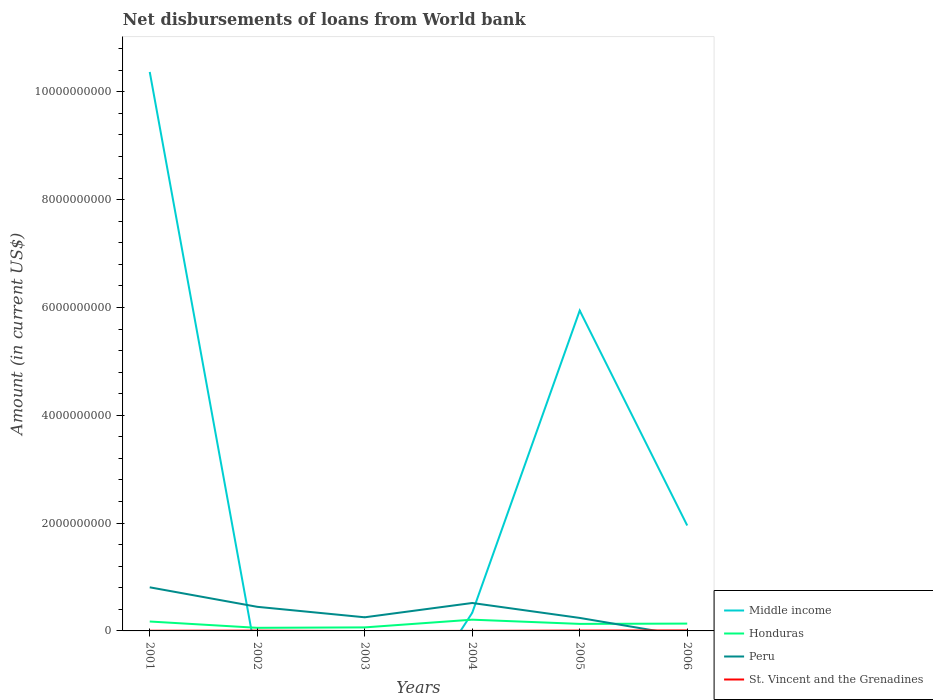Does the line corresponding to Peru intersect with the line corresponding to Honduras?
Give a very brief answer. Yes. Is the number of lines equal to the number of legend labels?
Make the answer very short. No. What is the total amount of loan disbursed from World Bank in St. Vincent and the Grenadines in the graph?
Offer a terse response. -5.86e+06. What is the difference between the highest and the second highest amount of loan disbursed from World Bank in St. Vincent and the Grenadines?
Your answer should be compact. 8.95e+06. How many lines are there?
Ensure brevity in your answer.  4. Where does the legend appear in the graph?
Make the answer very short. Bottom right. How many legend labels are there?
Offer a terse response. 4. How are the legend labels stacked?
Keep it short and to the point. Vertical. What is the title of the graph?
Provide a succinct answer. Net disbursements of loans from World bank. Does "Cayman Islands" appear as one of the legend labels in the graph?
Your response must be concise. No. What is the label or title of the X-axis?
Make the answer very short. Years. What is the Amount (in current US$) of Middle income in 2001?
Provide a short and direct response. 1.04e+1. What is the Amount (in current US$) in Honduras in 2001?
Make the answer very short. 1.75e+08. What is the Amount (in current US$) in Peru in 2001?
Offer a very short reply. 8.09e+08. What is the Amount (in current US$) in St. Vincent and the Grenadines in 2001?
Provide a succinct answer. 3.09e+06. What is the Amount (in current US$) in Middle income in 2002?
Provide a succinct answer. 0. What is the Amount (in current US$) in Honduras in 2002?
Keep it short and to the point. 5.75e+07. What is the Amount (in current US$) in Peru in 2002?
Provide a succinct answer. 4.47e+08. What is the Amount (in current US$) in St. Vincent and the Grenadines in 2002?
Your answer should be very brief. 5.45e+06. What is the Amount (in current US$) in Middle income in 2003?
Your answer should be very brief. 0. What is the Amount (in current US$) in Honduras in 2003?
Offer a very short reply. 6.55e+07. What is the Amount (in current US$) of Peru in 2003?
Give a very brief answer. 2.53e+08. What is the Amount (in current US$) of St. Vincent and the Grenadines in 2003?
Offer a terse response. 0. What is the Amount (in current US$) in Middle income in 2004?
Provide a short and direct response. 3.36e+08. What is the Amount (in current US$) in Honduras in 2004?
Your answer should be compact. 2.09e+08. What is the Amount (in current US$) of Peru in 2004?
Your answer should be compact. 5.18e+08. What is the Amount (in current US$) of St. Vincent and the Grenadines in 2004?
Offer a terse response. 4.46e+05. What is the Amount (in current US$) in Middle income in 2005?
Keep it short and to the point. 5.94e+09. What is the Amount (in current US$) of Honduras in 2005?
Your response must be concise. 1.31e+08. What is the Amount (in current US$) of Peru in 2005?
Your answer should be very brief. 2.41e+08. What is the Amount (in current US$) in St. Vincent and the Grenadines in 2005?
Your answer should be compact. 6.60e+06. What is the Amount (in current US$) of Middle income in 2006?
Ensure brevity in your answer.  1.96e+09. What is the Amount (in current US$) in Honduras in 2006?
Provide a succinct answer. 1.36e+08. What is the Amount (in current US$) of Peru in 2006?
Provide a short and direct response. 0. What is the Amount (in current US$) of St. Vincent and the Grenadines in 2006?
Ensure brevity in your answer.  8.95e+06. Across all years, what is the maximum Amount (in current US$) in Middle income?
Your response must be concise. 1.04e+1. Across all years, what is the maximum Amount (in current US$) in Honduras?
Offer a terse response. 2.09e+08. Across all years, what is the maximum Amount (in current US$) of Peru?
Your answer should be very brief. 8.09e+08. Across all years, what is the maximum Amount (in current US$) of St. Vincent and the Grenadines?
Keep it short and to the point. 8.95e+06. Across all years, what is the minimum Amount (in current US$) in Middle income?
Offer a terse response. 0. Across all years, what is the minimum Amount (in current US$) in Honduras?
Make the answer very short. 5.75e+07. Across all years, what is the minimum Amount (in current US$) of Peru?
Make the answer very short. 0. Across all years, what is the minimum Amount (in current US$) of St. Vincent and the Grenadines?
Ensure brevity in your answer.  0. What is the total Amount (in current US$) of Middle income in the graph?
Make the answer very short. 1.86e+1. What is the total Amount (in current US$) in Honduras in the graph?
Offer a terse response. 7.73e+08. What is the total Amount (in current US$) of Peru in the graph?
Your answer should be compact. 2.27e+09. What is the total Amount (in current US$) of St. Vincent and the Grenadines in the graph?
Ensure brevity in your answer.  2.45e+07. What is the difference between the Amount (in current US$) in Honduras in 2001 and that in 2002?
Make the answer very short. 1.17e+08. What is the difference between the Amount (in current US$) of Peru in 2001 and that in 2002?
Make the answer very short. 3.62e+08. What is the difference between the Amount (in current US$) of St. Vincent and the Grenadines in 2001 and that in 2002?
Make the answer very short. -2.36e+06. What is the difference between the Amount (in current US$) in Honduras in 2001 and that in 2003?
Your response must be concise. 1.09e+08. What is the difference between the Amount (in current US$) of Peru in 2001 and that in 2003?
Ensure brevity in your answer.  5.56e+08. What is the difference between the Amount (in current US$) of Middle income in 2001 and that in 2004?
Offer a very short reply. 1.00e+1. What is the difference between the Amount (in current US$) of Honduras in 2001 and that in 2004?
Your response must be concise. -3.41e+07. What is the difference between the Amount (in current US$) in Peru in 2001 and that in 2004?
Your answer should be very brief. 2.91e+08. What is the difference between the Amount (in current US$) in St. Vincent and the Grenadines in 2001 and that in 2004?
Keep it short and to the point. 2.64e+06. What is the difference between the Amount (in current US$) in Middle income in 2001 and that in 2005?
Provide a short and direct response. 4.43e+09. What is the difference between the Amount (in current US$) in Honduras in 2001 and that in 2005?
Provide a short and direct response. 4.41e+07. What is the difference between the Amount (in current US$) of Peru in 2001 and that in 2005?
Offer a terse response. 5.68e+08. What is the difference between the Amount (in current US$) of St. Vincent and the Grenadines in 2001 and that in 2005?
Ensure brevity in your answer.  -3.51e+06. What is the difference between the Amount (in current US$) of Middle income in 2001 and that in 2006?
Make the answer very short. 8.41e+09. What is the difference between the Amount (in current US$) of Honduras in 2001 and that in 2006?
Provide a short and direct response. 3.87e+07. What is the difference between the Amount (in current US$) of St. Vincent and the Grenadines in 2001 and that in 2006?
Your answer should be very brief. -5.86e+06. What is the difference between the Amount (in current US$) of Honduras in 2002 and that in 2003?
Offer a very short reply. -8.01e+06. What is the difference between the Amount (in current US$) in Peru in 2002 and that in 2003?
Offer a very short reply. 1.94e+08. What is the difference between the Amount (in current US$) in Honduras in 2002 and that in 2004?
Your response must be concise. -1.51e+08. What is the difference between the Amount (in current US$) of Peru in 2002 and that in 2004?
Offer a terse response. -7.11e+07. What is the difference between the Amount (in current US$) of St. Vincent and the Grenadines in 2002 and that in 2004?
Your answer should be compact. 5.00e+06. What is the difference between the Amount (in current US$) in Honduras in 2002 and that in 2005?
Offer a very short reply. -7.30e+07. What is the difference between the Amount (in current US$) of Peru in 2002 and that in 2005?
Provide a short and direct response. 2.06e+08. What is the difference between the Amount (in current US$) in St. Vincent and the Grenadines in 2002 and that in 2005?
Your answer should be compact. -1.15e+06. What is the difference between the Amount (in current US$) in Honduras in 2002 and that in 2006?
Provide a succinct answer. -7.85e+07. What is the difference between the Amount (in current US$) of St. Vincent and the Grenadines in 2002 and that in 2006?
Offer a very short reply. -3.50e+06. What is the difference between the Amount (in current US$) of Honduras in 2003 and that in 2004?
Offer a terse response. -1.43e+08. What is the difference between the Amount (in current US$) of Peru in 2003 and that in 2004?
Your answer should be compact. -2.65e+08. What is the difference between the Amount (in current US$) in Honduras in 2003 and that in 2005?
Ensure brevity in your answer.  -6.50e+07. What is the difference between the Amount (in current US$) of Peru in 2003 and that in 2005?
Make the answer very short. 1.18e+07. What is the difference between the Amount (in current US$) of Honduras in 2003 and that in 2006?
Your answer should be compact. -7.04e+07. What is the difference between the Amount (in current US$) of Middle income in 2004 and that in 2005?
Provide a succinct answer. -5.61e+09. What is the difference between the Amount (in current US$) in Honduras in 2004 and that in 2005?
Your response must be concise. 7.82e+07. What is the difference between the Amount (in current US$) in Peru in 2004 and that in 2005?
Your answer should be compact. 2.77e+08. What is the difference between the Amount (in current US$) of St. Vincent and the Grenadines in 2004 and that in 2005?
Your answer should be very brief. -6.16e+06. What is the difference between the Amount (in current US$) in Middle income in 2004 and that in 2006?
Provide a succinct answer. -1.62e+09. What is the difference between the Amount (in current US$) of Honduras in 2004 and that in 2006?
Give a very brief answer. 7.27e+07. What is the difference between the Amount (in current US$) of St. Vincent and the Grenadines in 2004 and that in 2006?
Offer a very short reply. -8.50e+06. What is the difference between the Amount (in current US$) in Middle income in 2005 and that in 2006?
Your answer should be very brief. 3.99e+09. What is the difference between the Amount (in current US$) of Honduras in 2005 and that in 2006?
Make the answer very short. -5.49e+06. What is the difference between the Amount (in current US$) of St. Vincent and the Grenadines in 2005 and that in 2006?
Ensure brevity in your answer.  -2.34e+06. What is the difference between the Amount (in current US$) in Middle income in 2001 and the Amount (in current US$) in Honduras in 2002?
Your response must be concise. 1.03e+1. What is the difference between the Amount (in current US$) of Middle income in 2001 and the Amount (in current US$) of Peru in 2002?
Provide a short and direct response. 9.92e+09. What is the difference between the Amount (in current US$) in Middle income in 2001 and the Amount (in current US$) in St. Vincent and the Grenadines in 2002?
Your answer should be compact. 1.04e+1. What is the difference between the Amount (in current US$) of Honduras in 2001 and the Amount (in current US$) of Peru in 2002?
Make the answer very short. -2.72e+08. What is the difference between the Amount (in current US$) of Honduras in 2001 and the Amount (in current US$) of St. Vincent and the Grenadines in 2002?
Ensure brevity in your answer.  1.69e+08. What is the difference between the Amount (in current US$) of Peru in 2001 and the Amount (in current US$) of St. Vincent and the Grenadines in 2002?
Ensure brevity in your answer.  8.03e+08. What is the difference between the Amount (in current US$) of Middle income in 2001 and the Amount (in current US$) of Honduras in 2003?
Make the answer very short. 1.03e+1. What is the difference between the Amount (in current US$) in Middle income in 2001 and the Amount (in current US$) in Peru in 2003?
Offer a terse response. 1.01e+1. What is the difference between the Amount (in current US$) in Honduras in 2001 and the Amount (in current US$) in Peru in 2003?
Give a very brief answer. -7.83e+07. What is the difference between the Amount (in current US$) in Middle income in 2001 and the Amount (in current US$) in Honduras in 2004?
Your response must be concise. 1.02e+1. What is the difference between the Amount (in current US$) of Middle income in 2001 and the Amount (in current US$) of Peru in 2004?
Keep it short and to the point. 9.85e+09. What is the difference between the Amount (in current US$) of Middle income in 2001 and the Amount (in current US$) of St. Vincent and the Grenadines in 2004?
Your answer should be very brief. 1.04e+1. What is the difference between the Amount (in current US$) of Honduras in 2001 and the Amount (in current US$) of Peru in 2004?
Offer a very short reply. -3.44e+08. What is the difference between the Amount (in current US$) in Honduras in 2001 and the Amount (in current US$) in St. Vincent and the Grenadines in 2004?
Offer a terse response. 1.74e+08. What is the difference between the Amount (in current US$) in Peru in 2001 and the Amount (in current US$) in St. Vincent and the Grenadines in 2004?
Your answer should be very brief. 8.08e+08. What is the difference between the Amount (in current US$) of Middle income in 2001 and the Amount (in current US$) of Honduras in 2005?
Offer a very short reply. 1.02e+1. What is the difference between the Amount (in current US$) in Middle income in 2001 and the Amount (in current US$) in Peru in 2005?
Provide a short and direct response. 1.01e+1. What is the difference between the Amount (in current US$) of Middle income in 2001 and the Amount (in current US$) of St. Vincent and the Grenadines in 2005?
Give a very brief answer. 1.04e+1. What is the difference between the Amount (in current US$) of Honduras in 2001 and the Amount (in current US$) of Peru in 2005?
Ensure brevity in your answer.  -6.65e+07. What is the difference between the Amount (in current US$) in Honduras in 2001 and the Amount (in current US$) in St. Vincent and the Grenadines in 2005?
Your response must be concise. 1.68e+08. What is the difference between the Amount (in current US$) in Peru in 2001 and the Amount (in current US$) in St. Vincent and the Grenadines in 2005?
Your response must be concise. 8.02e+08. What is the difference between the Amount (in current US$) in Middle income in 2001 and the Amount (in current US$) in Honduras in 2006?
Provide a succinct answer. 1.02e+1. What is the difference between the Amount (in current US$) in Middle income in 2001 and the Amount (in current US$) in St. Vincent and the Grenadines in 2006?
Offer a terse response. 1.04e+1. What is the difference between the Amount (in current US$) in Honduras in 2001 and the Amount (in current US$) in St. Vincent and the Grenadines in 2006?
Provide a succinct answer. 1.66e+08. What is the difference between the Amount (in current US$) in Peru in 2001 and the Amount (in current US$) in St. Vincent and the Grenadines in 2006?
Provide a succinct answer. 8.00e+08. What is the difference between the Amount (in current US$) in Honduras in 2002 and the Amount (in current US$) in Peru in 2003?
Ensure brevity in your answer.  -1.95e+08. What is the difference between the Amount (in current US$) in Honduras in 2002 and the Amount (in current US$) in Peru in 2004?
Give a very brief answer. -4.61e+08. What is the difference between the Amount (in current US$) in Honduras in 2002 and the Amount (in current US$) in St. Vincent and the Grenadines in 2004?
Offer a very short reply. 5.71e+07. What is the difference between the Amount (in current US$) in Peru in 2002 and the Amount (in current US$) in St. Vincent and the Grenadines in 2004?
Offer a terse response. 4.47e+08. What is the difference between the Amount (in current US$) in Honduras in 2002 and the Amount (in current US$) in Peru in 2005?
Your response must be concise. -1.84e+08. What is the difference between the Amount (in current US$) in Honduras in 2002 and the Amount (in current US$) in St. Vincent and the Grenadines in 2005?
Provide a short and direct response. 5.09e+07. What is the difference between the Amount (in current US$) in Peru in 2002 and the Amount (in current US$) in St. Vincent and the Grenadines in 2005?
Provide a short and direct response. 4.40e+08. What is the difference between the Amount (in current US$) in Honduras in 2002 and the Amount (in current US$) in St. Vincent and the Grenadines in 2006?
Your answer should be very brief. 4.86e+07. What is the difference between the Amount (in current US$) of Peru in 2002 and the Amount (in current US$) of St. Vincent and the Grenadines in 2006?
Give a very brief answer. 4.38e+08. What is the difference between the Amount (in current US$) of Honduras in 2003 and the Amount (in current US$) of Peru in 2004?
Your response must be concise. -4.53e+08. What is the difference between the Amount (in current US$) in Honduras in 2003 and the Amount (in current US$) in St. Vincent and the Grenadines in 2004?
Keep it short and to the point. 6.51e+07. What is the difference between the Amount (in current US$) of Peru in 2003 and the Amount (in current US$) of St. Vincent and the Grenadines in 2004?
Ensure brevity in your answer.  2.52e+08. What is the difference between the Amount (in current US$) of Honduras in 2003 and the Amount (in current US$) of Peru in 2005?
Your answer should be very brief. -1.76e+08. What is the difference between the Amount (in current US$) in Honduras in 2003 and the Amount (in current US$) in St. Vincent and the Grenadines in 2005?
Your response must be concise. 5.89e+07. What is the difference between the Amount (in current US$) in Peru in 2003 and the Amount (in current US$) in St. Vincent and the Grenadines in 2005?
Offer a very short reply. 2.46e+08. What is the difference between the Amount (in current US$) of Honduras in 2003 and the Amount (in current US$) of St. Vincent and the Grenadines in 2006?
Your answer should be compact. 5.66e+07. What is the difference between the Amount (in current US$) of Peru in 2003 and the Amount (in current US$) of St. Vincent and the Grenadines in 2006?
Your answer should be very brief. 2.44e+08. What is the difference between the Amount (in current US$) of Middle income in 2004 and the Amount (in current US$) of Honduras in 2005?
Your answer should be compact. 2.06e+08. What is the difference between the Amount (in current US$) in Middle income in 2004 and the Amount (in current US$) in Peru in 2005?
Make the answer very short. 9.50e+07. What is the difference between the Amount (in current US$) in Middle income in 2004 and the Amount (in current US$) in St. Vincent and the Grenadines in 2005?
Provide a succinct answer. 3.30e+08. What is the difference between the Amount (in current US$) in Honduras in 2004 and the Amount (in current US$) in Peru in 2005?
Your answer should be very brief. -3.24e+07. What is the difference between the Amount (in current US$) of Honduras in 2004 and the Amount (in current US$) of St. Vincent and the Grenadines in 2005?
Provide a short and direct response. 2.02e+08. What is the difference between the Amount (in current US$) of Peru in 2004 and the Amount (in current US$) of St. Vincent and the Grenadines in 2005?
Give a very brief answer. 5.12e+08. What is the difference between the Amount (in current US$) in Middle income in 2004 and the Amount (in current US$) in Honduras in 2006?
Keep it short and to the point. 2.00e+08. What is the difference between the Amount (in current US$) of Middle income in 2004 and the Amount (in current US$) of St. Vincent and the Grenadines in 2006?
Offer a terse response. 3.27e+08. What is the difference between the Amount (in current US$) of Honduras in 2004 and the Amount (in current US$) of St. Vincent and the Grenadines in 2006?
Your answer should be very brief. 2.00e+08. What is the difference between the Amount (in current US$) in Peru in 2004 and the Amount (in current US$) in St. Vincent and the Grenadines in 2006?
Give a very brief answer. 5.09e+08. What is the difference between the Amount (in current US$) of Middle income in 2005 and the Amount (in current US$) of Honduras in 2006?
Give a very brief answer. 5.81e+09. What is the difference between the Amount (in current US$) in Middle income in 2005 and the Amount (in current US$) in St. Vincent and the Grenadines in 2006?
Give a very brief answer. 5.93e+09. What is the difference between the Amount (in current US$) of Honduras in 2005 and the Amount (in current US$) of St. Vincent and the Grenadines in 2006?
Give a very brief answer. 1.22e+08. What is the difference between the Amount (in current US$) in Peru in 2005 and the Amount (in current US$) in St. Vincent and the Grenadines in 2006?
Offer a very short reply. 2.32e+08. What is the average Amount (in current US$) in Middle income per year?
Offer a terse response. 3.10e+09. What is the average Amount (in current US$) in Honduras per year?
Ensure brevity in your answer.  1.29e+08. What is the average Amount (in current US$) in Peru per year?
Make the answer very short. 3.78e+08. What is the average Amount (in current US$) of St. Vincent and the Grenadines per year?
Provide a succinct answer. 4.09e+06. In the year 2001, what is the difference between the Amount (in current US$) of Middle income and Amount (in current US$) of Honduras?
Keep it short and to the point. 1.02e+1. In the year 2001, what is the difference between the Amount (in current US$) in Middle income and Amount (in current US$) in Peru?
Offer a terse response. 9.56e+09. In the year 2001, what is the difference between the Amount (in current US$) of Middle income and Amount (in current US$) of St. Vincent and the Grenadines?
Your answer should be very brief. 1.04e+1. In the year 2001, what is the difference between the Amount (in current US$) in Honduras and Amount (in current US$) in Peru?
Provide a succinct answer. -6.34e+08. In the year 2001, what is the difference between the Amount (in current US$) in Honduras and Amount (in current US$) in St. Vincent and the Grenadines?
Keep it short and to the point. 1.72e+08. In the year 2001, what is the difference between the Amount (in current US$) in Peru and Amount (in current US$) in St. Vincent and the Grenadines?
Offer a very short reply. 8.06e+08. In the year 2002, what is the difference between the Amount (in current US$) of Honduras and Amount (in current US$) of Peru?
Offer a very short reply. -3.90e+08. In the year 2002, what is the difference between the Amount (in current US$) of Honduras and Amount (in current US$) of St. Vincent and the Grenadines?
Your answer should be compact. 5.21e+07. In the year 2002, what is the difference between the Amount (in current US$) in Peru and Amount (in current US$) in St. Vincent and the Grenadines?
Offer a very short reply. 4.42e+08. In the year 2003, what is the difference between the Amount (in current US$) in Honduras and Amount (in current US$) in Peru?
Provide a short and direct response. -1.87e+08. In the year 2004, what is the difference between the Amount (in current US$) in Middle income and Amount (in current US$) in Honduras?
Offer a terse response. 1.27e+08. In the year 2004, what is the difference between the Amount (in current US$) in Middle income and Amount (in current US$) in Peru?
Offer a very short reply. -1.82e+08. In the year 2004, what is the difference between the Amount (in current US$) of Middle income and Amount (in current US$) of St. Vincent and the Grenadines?
Provide a short and direct response. 3.36e+08. In the year 2004, what is the difference between the Amount (in current US$) in Honduras and Amount (in current US$) in Peru?
Give a very brief answer. -3.09e+08. In the year 2004, what is the difference between the Amount (in current US$) of Honduras and Amount (in current US$) of St. Vincent and the Grenadines?
Provide a short and direct response. 2.08e+08. In the year 2004, what is the difference between the Amount (in current US$) in Peru and Amount (in current US$) in St. Vincent and the Grenadines?
Provide a short and direct response. 5.18e+08. In the year 2005, what is the difference between the Amount (in current US$) of Middle income and Amount (in current US$) of Honduras?
Provide a short and direct response. 5.81e+09. In the year 2005, what is the difference between the Amount (in current US$) in Middle income and Amount (in current US$) in Peru?
Offer a very short reply. 5.70e+09. In the year 2005, what is the difference between the Amount (in current US$) of Middle income and Amount (in current US$) of St. Vincent and the Grenadines?
Your answer should be very brief. 5.94e+09. In the year 2005, what is the difference between the Amount (in current US$) in Honduras and Amount (in current US$) in Peru?
Your answer should be very brief. -1.11e+08. In the year 2005, what is the difference between the Amount (in current US$) of Honduras and Amount (in current US$) of St. Vincent and the Grenadines?
Ensure brevity in your answer.  1.24e+08. In the year 2005, what is the difference between the Amount (in current US$) in Peru and Amount (in current US$) in St. Vincent and the Grenadines?
Ensure brevity in your answer.  2.35e+08. In the year 2006, what is the difference between the Amount (in current US$) of Middle income and Amount (in current US$) of Honduras?
Provide a succinct answer. 1.82e+09. In the year 2006, what is the difference between the Amount (in current US$) in Middle income and Amount (in current US$) in St. Vincent and the Grenadines?
Your answer should be very brief. 1.95e+09. In the year 2006, what is the difference between the Amount (in current US$) in Honduras and Amount (in current US$) in St. Vincent and the Grenadines?
Keep it short and to the point. 1.27e+08. What is the ratio of the Amount (in current US$) of Honduras in 2001 to that in 2002?
Provide a succinct answer. 3.04. What is the ratio of the Amount (in current US$) in Peru in 2001 to that in 2002?
Offer a very short reply. 1.81. What is the ratio of the Amount (in current US$) in St. Vincent and the Grenadines in 2001 to that in 2002?
Ensure brevity in your answer.  0.57. What is the ratio of the Amount (in current US$) in Honduras in 2001 to that in 2003?
Provide a short and direct response. 2.66. What is the ratio of the Amount (in current US$) of Peru in 2001 to that in 2003?
Offer a terse response. 3.2. What is the ratio of the Amount (in current US$) of Middle income in 2001 to that in 2004?
Give a very brief answer. 30.85. What is the ratio of the Amount (in current US$) in Honduras in 2001 to that in 2004?
Make the answer very short. 0.84. What is the ratio of the Amount (in current US$) in Peru in 2001 to that in 2004?
Your response must be concise. 1.56. What is the ratio of the Amount (in current US$) of St. Vincent and the Grenadines in 2001 to that in 2004?
Offer a terse response. 6.93. What is the ratio of the Amount (in current US$) in Middle income in 2001 to that in 2005?
Make the answer very short. 1.74. What is the ratio of the Amount (in current US$) of Honduras in 2001 to that in 2005?
Your answer should be very brief. 1.34. What is the ratio of the Amount (in current US$) in Peru in 2001 to that in 2005?
Make the answer very short. 3.35. What is the ratio of the Amount (in current US$) in St. Vincent and the Grenadines in 2001 to that in 2005?
Your response must be concise. 0.47. What is the ratio of the Amount (in current US$) in Middle income in 2001 to that in 2006?
Your answer should be very brief. 5.3. What is the ratio of the Amount (in current US$) in Honduras in 2001 to that in 2006?
Make the answer very short. 1.28. What is the ratio of the Amount (in current US$) of St. Vincent and the Grenadines in 2001 to that in 2006?
Ensure brevity in your answer.  0.35. What is the ratio of the Amount (in current US$) of Honduras in 2002 to that in 2003?
Provide a short and direct response. 0.88. What is the ratio of the Amount (in current US$) in Peru in 2002 to that in 2003?
Ensure brevity in your answer.  1.77. What is the ratio of the Amount (in current US$) of Honduras in 2002 to that in 2004?
Offer a very short reply. 0.28. What is the ratio of the Amount (in current US$) of Peru in 2002 to that in 2004?
Give a very brief answer. 0.86. What is the ratio of the Amount (in current US$) in St. Vincent and the Grenadines in 2002 to that in 2004?
Offer a very short reply. 12.22. What is the ratio of the Amount (in current US$) of Honduras in 2002 to that in 2005?
Offer a terse response. 0.44. What is the ratio of the Amount (in current US$) in Peru in 2002 to that in 2005?
Provide a succinct answer. 1.85. What is the ratio of the Amount (in current US$) of St. Vincent and the Grenadines in 2002 to that in 2005?
Your response must be concise. 0.83. What is the ratio of the Amount (in current US$) in Honduras in 2002 to that in 2006?
Offer a terse response. 0.42. What is the ratio of the Amount (in current US$) of St. Vincent and the Grenadines in 2002 to that in 2006?
Make the answer very short. 0.61. What is the ratio of the Amount (in current US$) in Honduras in 2003 to that in 2004?
Provide a succinct answer. 0.31. What is the ratio of the Amount (in current US$) in Peru in 2003 to that in 2004?
Provide a succinct answer. 0.49. What is the ratio of the Amount (in current US$) in Honduras in 2003 to that in 2005?
Provide a short and direct response. 0.5. What is the ratio of the Amount (in current US$) in Peru in 2003 to that in 2005?
Your response must be concise. 1.05. What is the ratio of the Amount (in current US$) of Honduras in 2003 to that in 2006?
Offer a terse response. 0.48. What is the ratio of the Amount (in current US$) in Middle income in 2004 to that in 2005?
Provide a succinct answer. 0.06. What is the ratio of the Amount (in current US$) of Honduras in 2004 to that in 2005?
Provide a succinct answer. 1.6. What is the ratio of the Amount (in current US$) of Peru in 2004 to that in 2005?
Provide a succinct answer. 2.15. What is the ratio of the Amount (in current US$) of St. Vincent and the Grenadines in 2004 to that in 2005?
Provide a short and direct response. 0.07. What is the ratio of the Amount (in current US$) of Middle income in 2004 to that in 2006?
Keep it short and to the point. 0.17. What is the ratio of the Amount (in current US$) in Honduras in 2004 to that in 2006?
Make the answer very short. 1.53. What is the ratio of the Amount (in current US$) of St. Vincent and the Grenadines in 2004 to that in 2006?
Offer a very short reply. 0.05. What is the ratio of the Amount (in current US$) in Middle income in 2005 to that in 2006?
Your answer should be very brief. 3.04. What is the ratio of the Amount (in current US$) of Honduras in 2005 to that in 2006?
Make the answer very short. 0.96. What is the ratio of the Amount (in current US$) in St. Vincent and the Grenadines in 2005 to that in 2006?
Offer a very short reply. 0.74. What is the difference between the highest and the second highest Amount (in current US$) in Middle income?
Give a very brief answer. 4.43e+09. What is the difference between the highest and the second highest Amount (in current US$) in Honduras?
Your response must be concise. 3.41e+07. What is the difference between the highest and the second highest Amount (in current US$) in Peru?
Offer a terse response. 2.91e+08. What is the difference between the highest and the second highest Amount (in current US$) in St. Vincent and the Grenadines?
Give a very brief answer. 2.34e+06. What is the difference between the highest and the lowest Amount (in current US$) of Middle income?
Your answer should be compact. 1.04e+1. What is the difference between the highest and the lowest Amount (in current US$) in Honduras?
Ensure brevity in your answer.  1.51e+08. What is the difference between the highest and the lowest Amount (in current US$) of Peru?
Your answer should be very brief. 8.09e+08. What is the difference between the highest and the lowest Amount (in current US$) of St. Vincent and the Grenadines?
Offer a very short reply. 8.95e+06. 